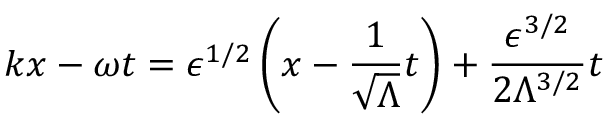<formula> <loc_0><loc_0><loc_500><loc_500>k x - \omega t = \epsilon ^ { 1 / 2 } \left ( x - \frac { 1 } { \sqrt { \Lambda } } t \right ) + \frac { \epsilon ^ { 3 / 2 } } { 2 \Lambda ^ { 3 / 2 } } t</formula> 